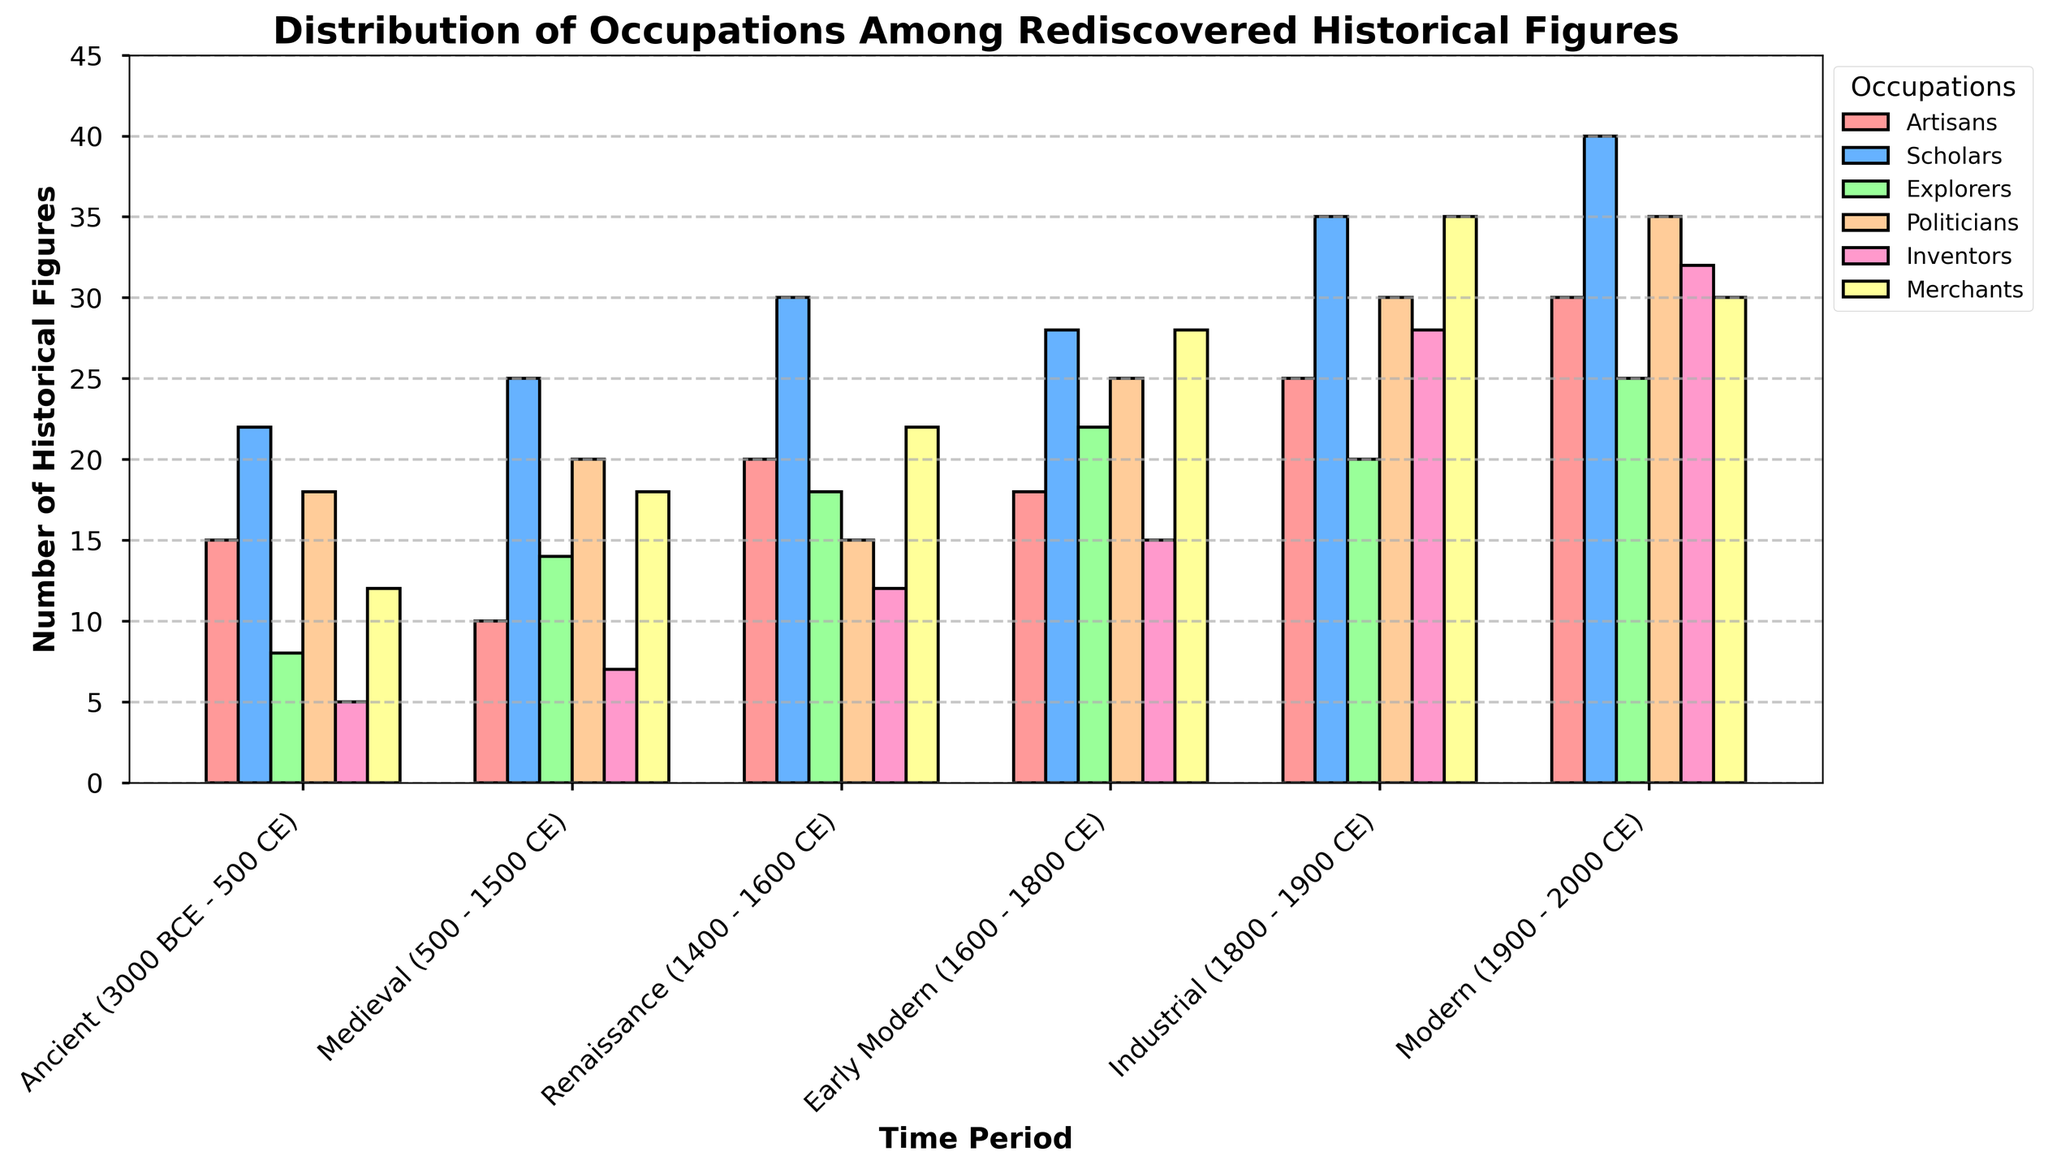Which time period has the highest number of Scholars? Look at the heights of the bars corresponding to 'Scholars' across all time periods. The tallest bar is in the 'Modern (1900 - 2000 CE)' period.
Answer: Modern (1900 - 2000 CE) How many Explorers were there during the Renaissance and Industrial periods combined? Add the number of Explorers during the Renaissance (18) and the number during the Industrial period (20). The sum is 18 + 20 = 38.
Answer: 38 Which occupation has the least representation in the Ancient time period? Compare the heights of all bars within the Ancient time period. The shortest bar corresponds to the 'Inventors' occupation with a value of 5.
Answer: Inventors How does the number of Merchants in the Early Modern period compare to the Medieval period? Look at the bars for 'Merchants' in both the Medieval (18) and Early Modern (28) periods. 28 is greater than 18.
Answer: Greater in Early Modern What's the average number of Politicians across all time periods? Sum the number of Politicians in each time period (18 + 20 + 15 + 25 + 30 + 35) which is 143. Divide this by the number of time periods (6). The average is 143 / 6 ≈ 23.83.
Answer: 23.83 Between which two time periods do Inventors show the most significant increase? Compare the differences in the number of Inventors between consecutive periods. The biggest increase happens between the Renaissance (12) and Early Modern (15) periods with an increase of 3. Between Early Modern (15) and Industrial (28) with the biggest increase of 13.
Answer: Early Modern and Industrial Which occupation saw the most consistent increase in numbers over time? Observe the trend for each occupation type across all time periods. The occupation 'Politicians' shows an increasing trend in every time period.
Answer: Politicians What is the total number of historical figures represented in the Modern period? Sum the number of figures in each occupation during the Modern period (30 + 40 + 25 + 35 + 32 + 30). The total sum is 192.
Answer: 192 Which occupation had the highest growth between the Renaissance and Industrial periods? Subtract the figures for each occupation in the Renaissance period from the Industrial period and find the largest difference. Merchants grew from 22 to 35, a difference of 13, which is the highest.
Answer: Merchants 